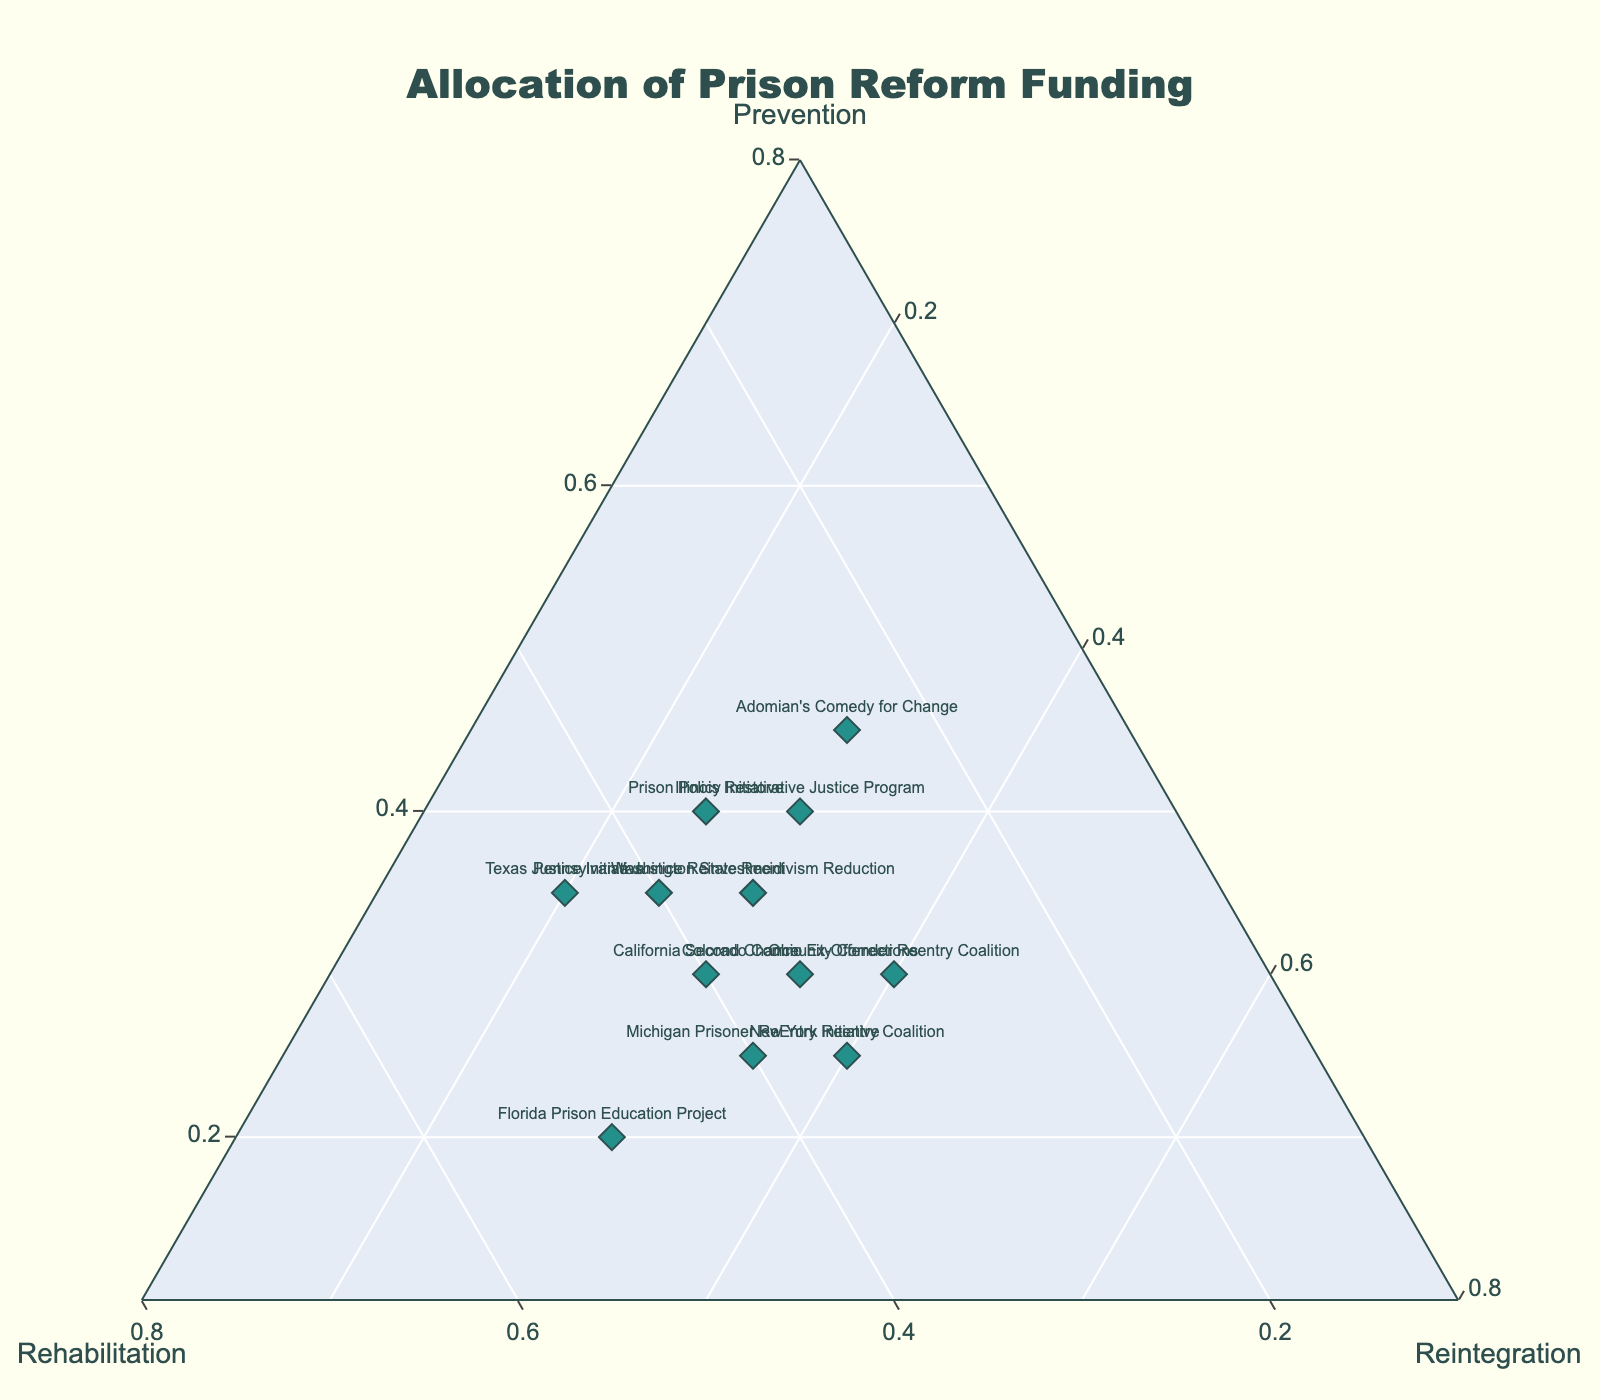What is the title of the figure? The title is located at the top center of the figure, typically larger and in bold compared to other text elements.
Answer: Allocation of Prison Reform Funding How many programs focus most on rehabilitation based on their highest normalized percentage? Review the plot points and hover over each to check the normalized percentages. Identify the ones with the highest percentage allocated to rehabilitation.
Answer: 3 Which program has the highest percentage allocated to prevention funding? Look at all the points and hover to see the normalized percentages. Identify the one with the highest prevention percentage.
Answer: Adomian's Comedy for Change What is the normalized percentage of reintegration funding for the Colorado Community Corrections program? Hover over the point labeled "Colorado Community Corrections" to see the normalized percentages for each category.
Answer: 35% How do the programs in Texas and Florida compare in terms of their allocation towards rehabilitation funding? Hover over both the "Texas Justice Initiative" and "Florida Prison Education Project." Compare their rehabilitation percentages.
Answer: Texas: 45%, Florida: 50% What percentage of funding do the Illinois Restorative Justice Program and the Pennsylvania Justice Reinvestment allocate to prevention combined? Hover over both points to find their prevention percentages. Add the two values together.
Answer: 75% Which program allocates the least percentage of funding to reintegration? Hover over all the points and compare the reintegration percentages. Identify the program with the lowest percentage.
Answer: Texas Justice Initiative How many programs allocate exactly 30% of their funding to reintegration? Count the points that, when hovered over, show a reintegration percentage of 30%.
Answer: 5 Which programs have an equal allocation to prevention and reintegration? Hover over each point and look for programs with equal values for prevention and reintegration percentages.
Answer: California Second Chance, Illinois Restorative Justice Program What is the combined normalized percentage of prevention funding for Ohio Ex-Offender Reentry Coalition and Michigan Prisoner ReEntry Initiative? Hover over the points for both programs to find their prevention percentages. Sum the percentages.
Answer: 55% 